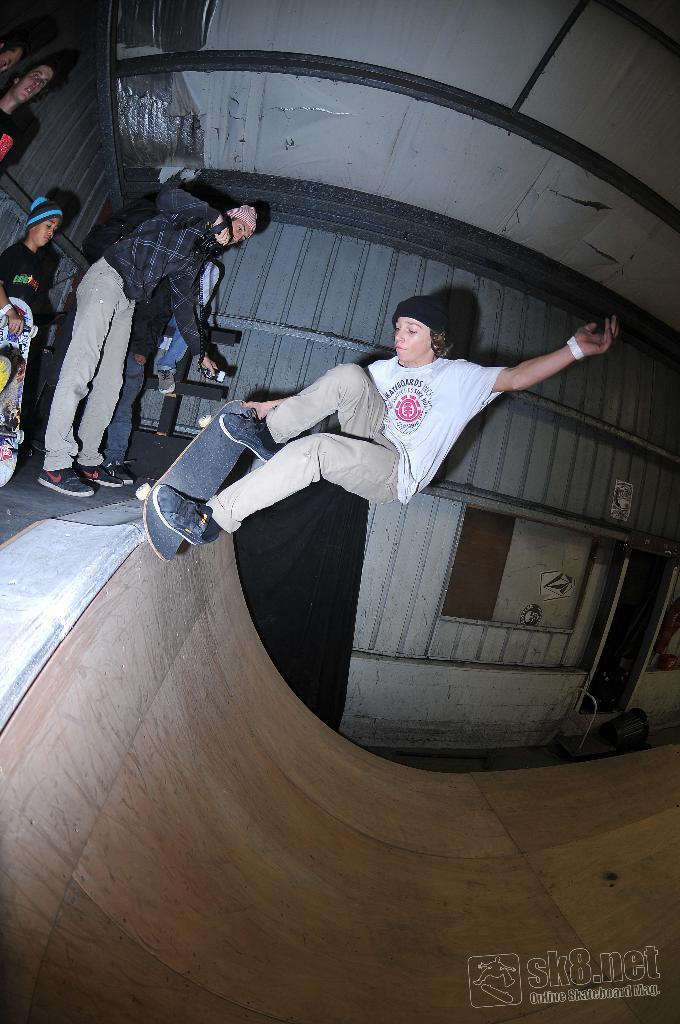Can you describe this image briefly? In this image, in the middle, we can see a man riding on the skateboard. On the left side, we can see a group of people. At the top, we can see a roof, at the bottom, we can see a floor. 